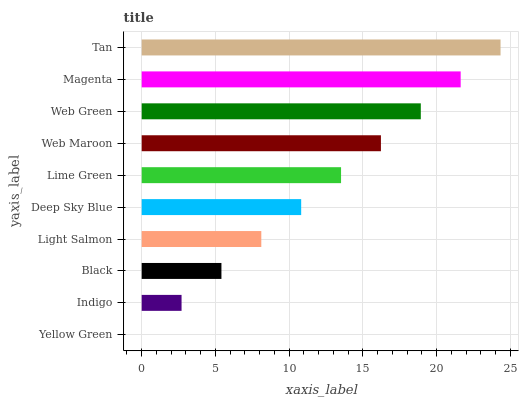Is Yellow Green the minimum?
Answer yes or no. Yes. Is Tan the maximum?
Answer yes or no. Yes. Is Indigo the minimum?
Answer yes or no. No. Is Indigo the maximum?
Answer yes or no. No. Is Indigo greater than Yellow Green?
Answer yes or no. Yes. Is Yellow Green less than Indigo?
Answer yes or no. Yes. Is Yellow Green greater than Indigo?
Answer yes or no. No. Is Indigo less than Yellow Green?
Answer yes or no. No. Is Lime Green the high median?
Answer yes or no. Yes. Is Deep Sky Blue the low median?
Answer yes or no. Yes. Is Web Maroon the high median?
Answer yes or no. No. Is Web Green the low median?
Answer yes or no. No. 